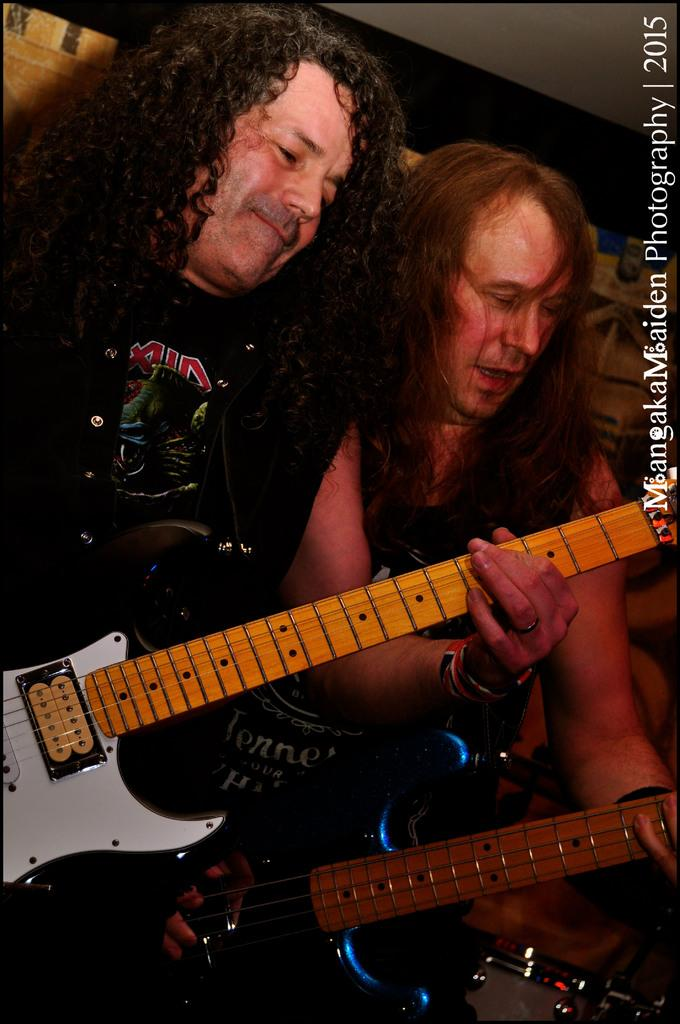How many people are in the image? There are two people in the image. What are the people holding in the image? Both people are holding guitars. What type of teeth can be seen on the guitars in the image? There are no teeth visible on the guitars in the image, as guitars do not have teeth. 